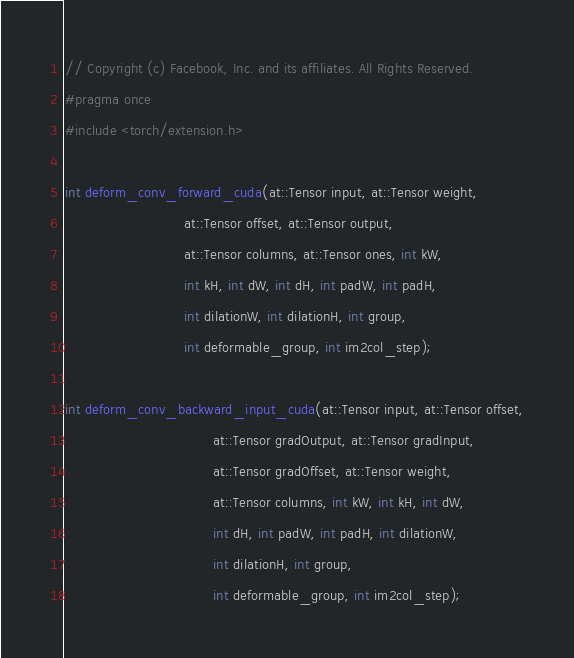<code> <loc_0><loc_0><loc_500><loc_500><_C++_>// Copyright (c) Facebook, Inc. and its affiliates. All Rights Reserved.
#pragma once
#include <torch/extension.h>

int deform_conv_forward_cuda(at::Tensor input, at::Tensor weight,
                             at::Tensor offset, at::Tensor output,
                             at::Tensor columns, at::Tensor ones, int kW,
                             int kH, int dW, int dH, int padW, int padH,
                             int dilationW, int dilationH, int group,
                             int deformable_group, int im2col_step);

int deform_conv_backward_input_cuda(at::Tensor input, at::Tensor offset,
                                    at::Tensor gradOutput, at::Tensor gradInput,
                                    at::Tensor gradOffset, at::Tensor weight,
                                    at::Tensor columns, int kW, int kH, int dW,
                                    int dH, int padW, int padH, int dilationW,
                                    int dilationH, int group,
                                    int deformable_group, int im2col_step);
</code> 